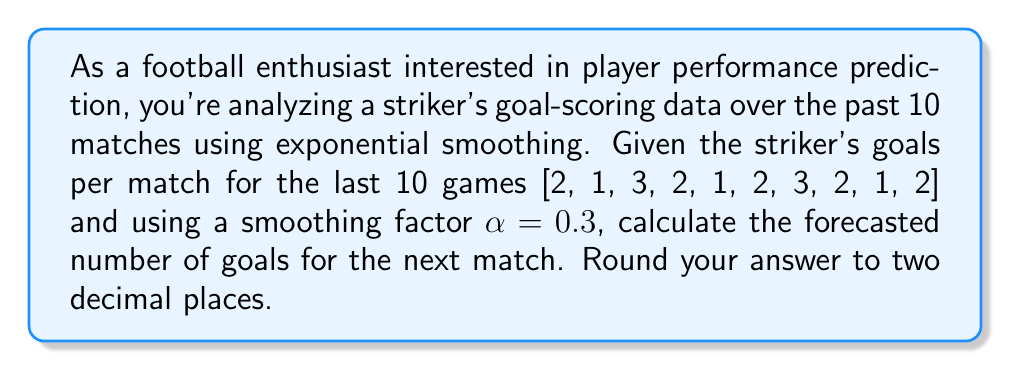Can you answer this question? To predict the striker's performance using exponential smoothing, we'll follow these steps:

1) The exponential smoothing formula is:
   $$ F_{t+1} = \alpha Y_t + (1-\alpha)F_t $$
   Where:
   $F_{t+1}$ is the forecast for the next period
   $Y_t$ is the actual value at time t
   $F_t$ is the forecast for the current period
   $\alpha$ is the smoothing factor (0.3 in this case)

2) We start by setting the initial forecast $F_1$ equal to the first actual value:
   $F_1 = 2$

3) We then calculate each subsequent forecast:
   $F_2 = 0.3(2) + 0.7(2) = 2$
   $F_3 = 0.3(1) + 0.7(2) = 1.7$
   $F_4 = 0.3(3) + 0.7(1.7) = 2.09$
   $F_5 = 0.3(2) + 0.7(2.09) = 2.063$
   $F_6 = 0.3(1) + 0.7(2.063) = 1.7441$
   $F_7 = 0.3(2) + 0.7(1.7441) = 1.82087$
   $F_8 = 0.3(3) + 0.7(1.82087) = 2.17461$
   $F_9 = 0.3(2) + 0.7(2.17461) = 2.12223$
   $F_{10} = 0.3(1) + 0.7(2.12223) = 1.78556$

4) Finally, we calculate the forecast for the next match (11th):
   $F_{11} = 0.3(2) + 0.7(1.78556) = 1.84989$

5) Rounding to two decimal places: 1.85
Answer: 1.85 goals 